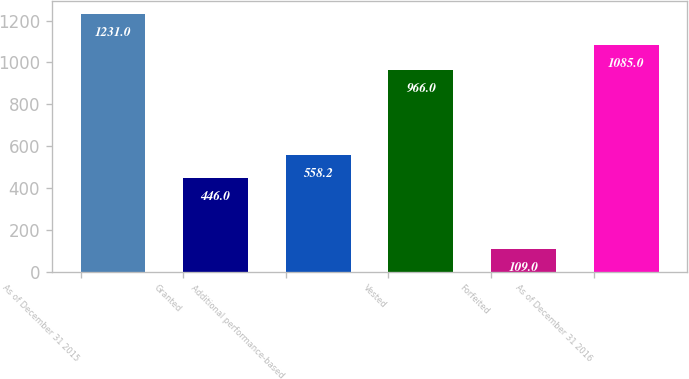Convert chart to OTSL. <chart><loc_0><loc_0><loc_500><loc_500><bar_chart><fcel>As of December 31 2015<fcel>Granted<fcel>Additional performance-based<fcel>Vested<fcel>Forfeited<fcel>As of December 31 2016<nl><fcel>1231<fcel>446<fcel>558.2<fcel>966<fcel>109<fcel>1085<nl></chart> 